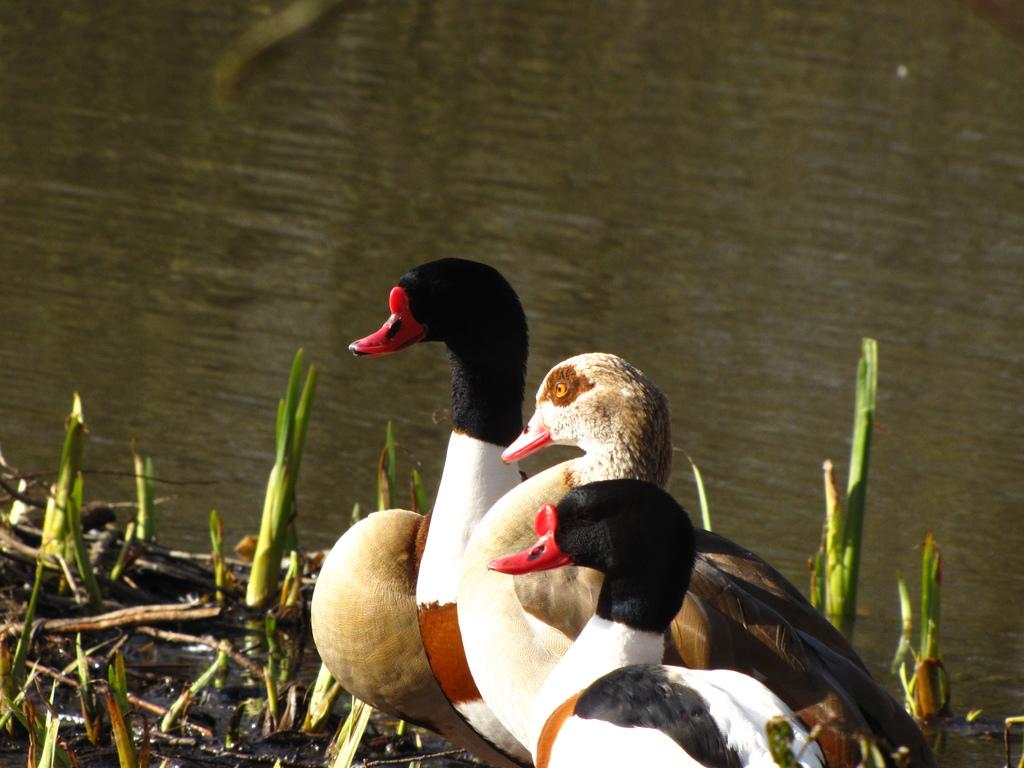What type of animals can be seen in the image? There are birds in the image. What colors are the birds in the image? The birds are in black, white, and brown colors. What can be seen in the background of the image? There is grass in the background of the image. What color is the grass in the image? The grass is green. What else is visible in the image besides the birds and grass? There is water visible in the image. What type of business are the men conducting in the image? There are no men present in the image, only birds, grass, and water. What kind of soap is being used to clean the birds in the image? There is no soap or cleaning activity depicted in the image; it features birds, grass, and water. 